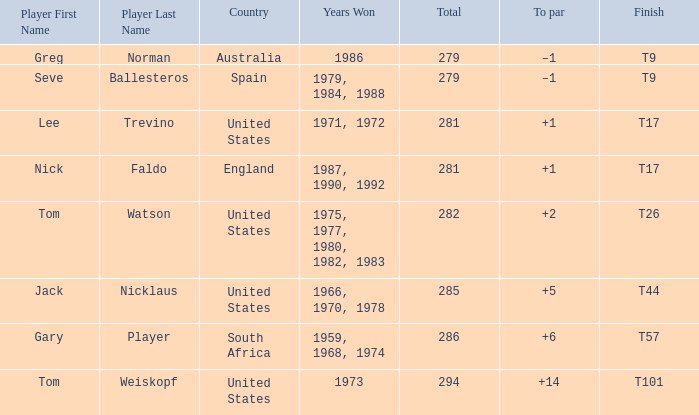Can you parse all the data within this table? {'header': ['Player First Name', 'Player Last Name', 'Country', 'Years Won', 'Total', 'To par', 'Finish'], 'rows': [['Greg', 'Norman', 'Australia', '1986', '279', '–1', 'T9'], ['Seve', 'Ballesteros', 'Spain', '1979, 1984, 1988', '279', '–1', 'T9'], ['Lee', 'Trevino', 'United States', '1971, 1972', '281', '+1', 'T17'], ['Nick', 'Faldo', 'England', '1987, 1990, 1992', '281', '+1', 'T17'], ['Tom', 'Watson', 'United States', '1975, 1977, 1980, 1982, 1983', '282', '+2', 'T26'], ['Jack', 'Nicklaus', 'United States', '1966, 1970, 1978', '285', '+5', 'T44'], ['Gary', 'Player', 'South Africa', '1959, 1968, 1974', '286', '+6', 'T57'], ['Tom', 'Weiskopf', 'United States', '1973', '294', '+14', 'T101']]} What is Australia's to par? –1. 